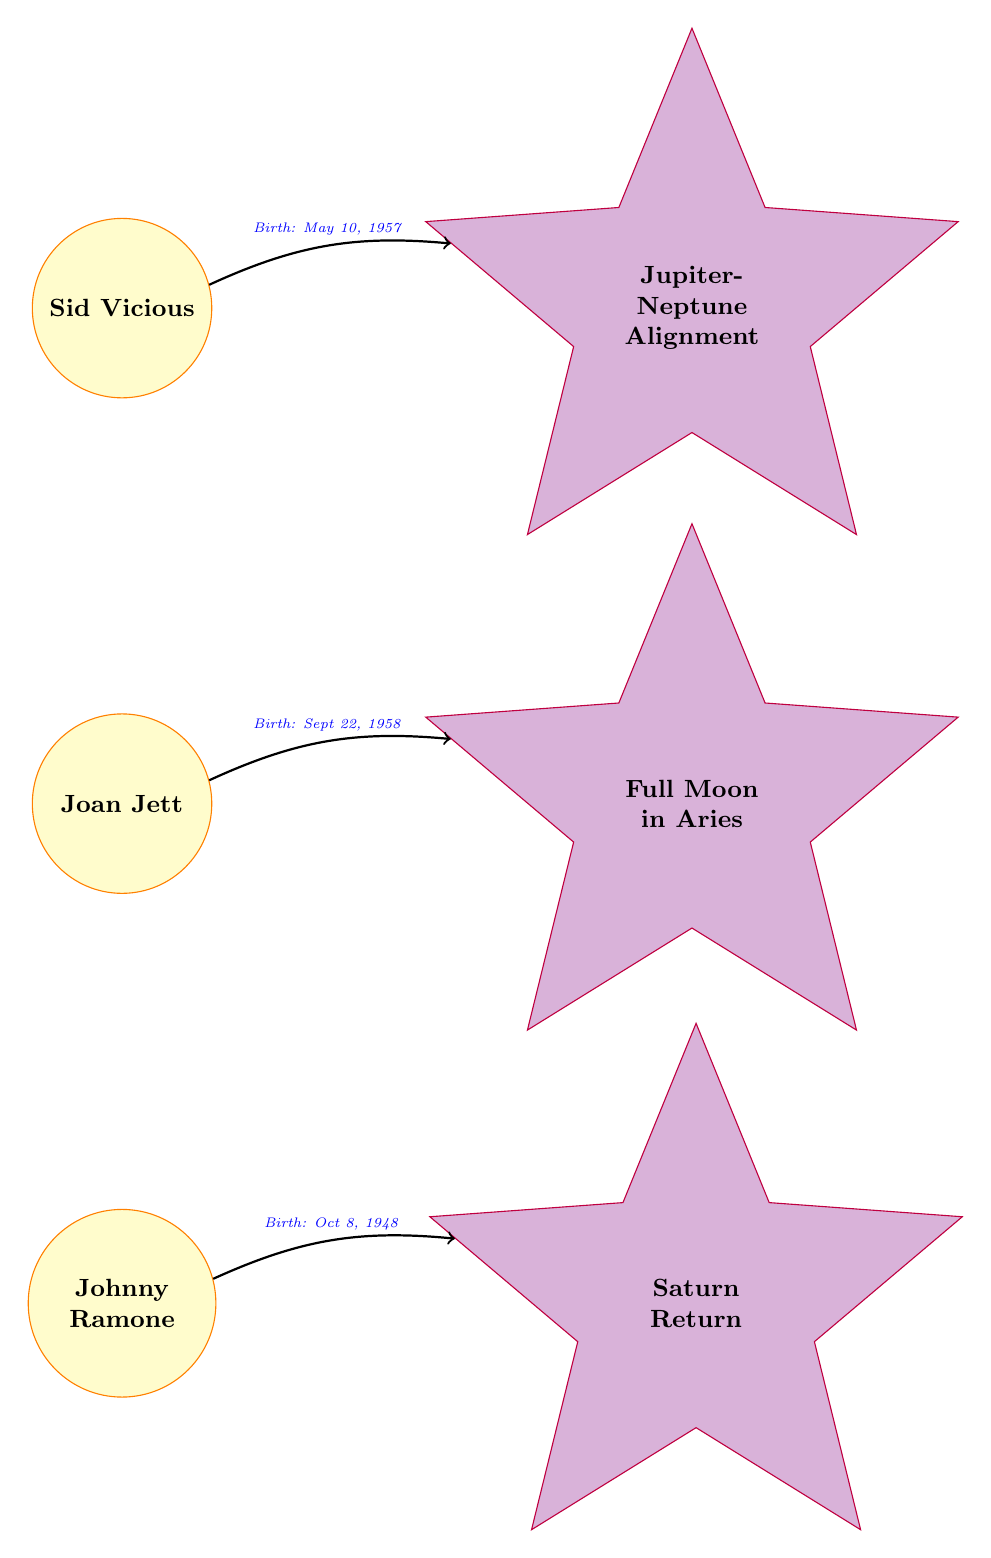What are the names of the three guitarists shown? The diagram lists Sid Vicious, Joan Jett, and Johnny Ramone as the three guitarists. Therefore, I can identify them directly from the nodes labeled as guitarist.
Answer: Sid Vicious, Joan Jett, Johnny Ramone What celestial event is associated with Sid Vicious? The diagram shows that Sid Vicious is connected to the Jupiter-Neptune Alignment, which is indicated as the celestial event related to him through an arrow.
Answer: Jupiter-Neptune Alignment Which guitarist's birthday is on September 22, 1958? By examining the diagram, Joan Jett's birth date is displayed next to her node, allowing me to identify her birthday clearly.
Answer: Joan Jett How many celestial events are depicted in the diagram? The diagram features three celestial events: Jupiter-Neptune Alignment, Full Moon in Aries, and Saturn Return, which can be counted directly from the celestial nodes.
Answer: 3 Which celestial event is linked to Johnny Ramone? I see that Johnny Ramone is connected by an edge to the Saturn Return node, making it clear that this is the celestial event associated with him.
Answer: Saturn Return What alignment is connected with Sid Vicious's birth date? The directed edge from Sid Vicious to the Jupiter-Neptune Alignment shows this alignment directly linked with his birth date, which allows me to determine the connection.
Answer: Jupiter-Neptune Alignment What is the birth date of Johnny Ramone? The diagram includes the birth date directly alongside Johnny Ramone's name, which makes it straightforward to answer.
Answer: Oct 8, 1948 What type of diagram is illustrated here? The structure and content, focusing on the relationships between guitarists and celestial events suggests this is an Astronomy Diagram.
Answer: Astronomy Diagram 